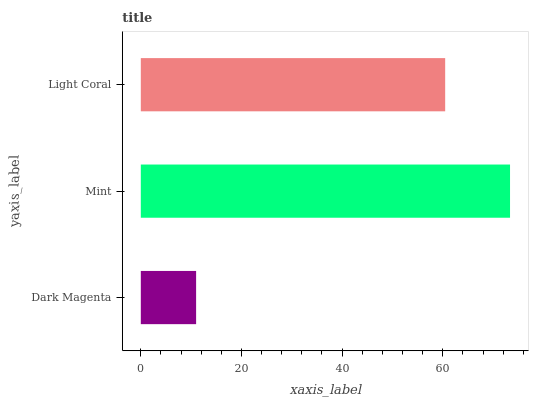Is Dark Magenta the minimum?
Answer yes or no. Yes. Is Mint the maximum?
Answer yes or no. Yes. Is Light Coral the minimum?
Answer yes or no. No. Is Light Coral the maximum?
Answer yes or no. No. Is Mint greater than Light Coral?
Answer yes or no. Yes. Is Light Coral less than Mint?
Answer yes or no. Yes. Is Light Coral greater than Mint?
Answer yes or no. No. Is Mint less than Light Coral?
Answer yes or no. No. Is Light Coral the high median?
Answer yes or no. Yes. Is Light Coral the low median?
Answer yes or no. Yes. Is Dark Magenta the high median?
Answer yes or no. No. Is Dark Magenta the low median?
Answer yes or no. No. 